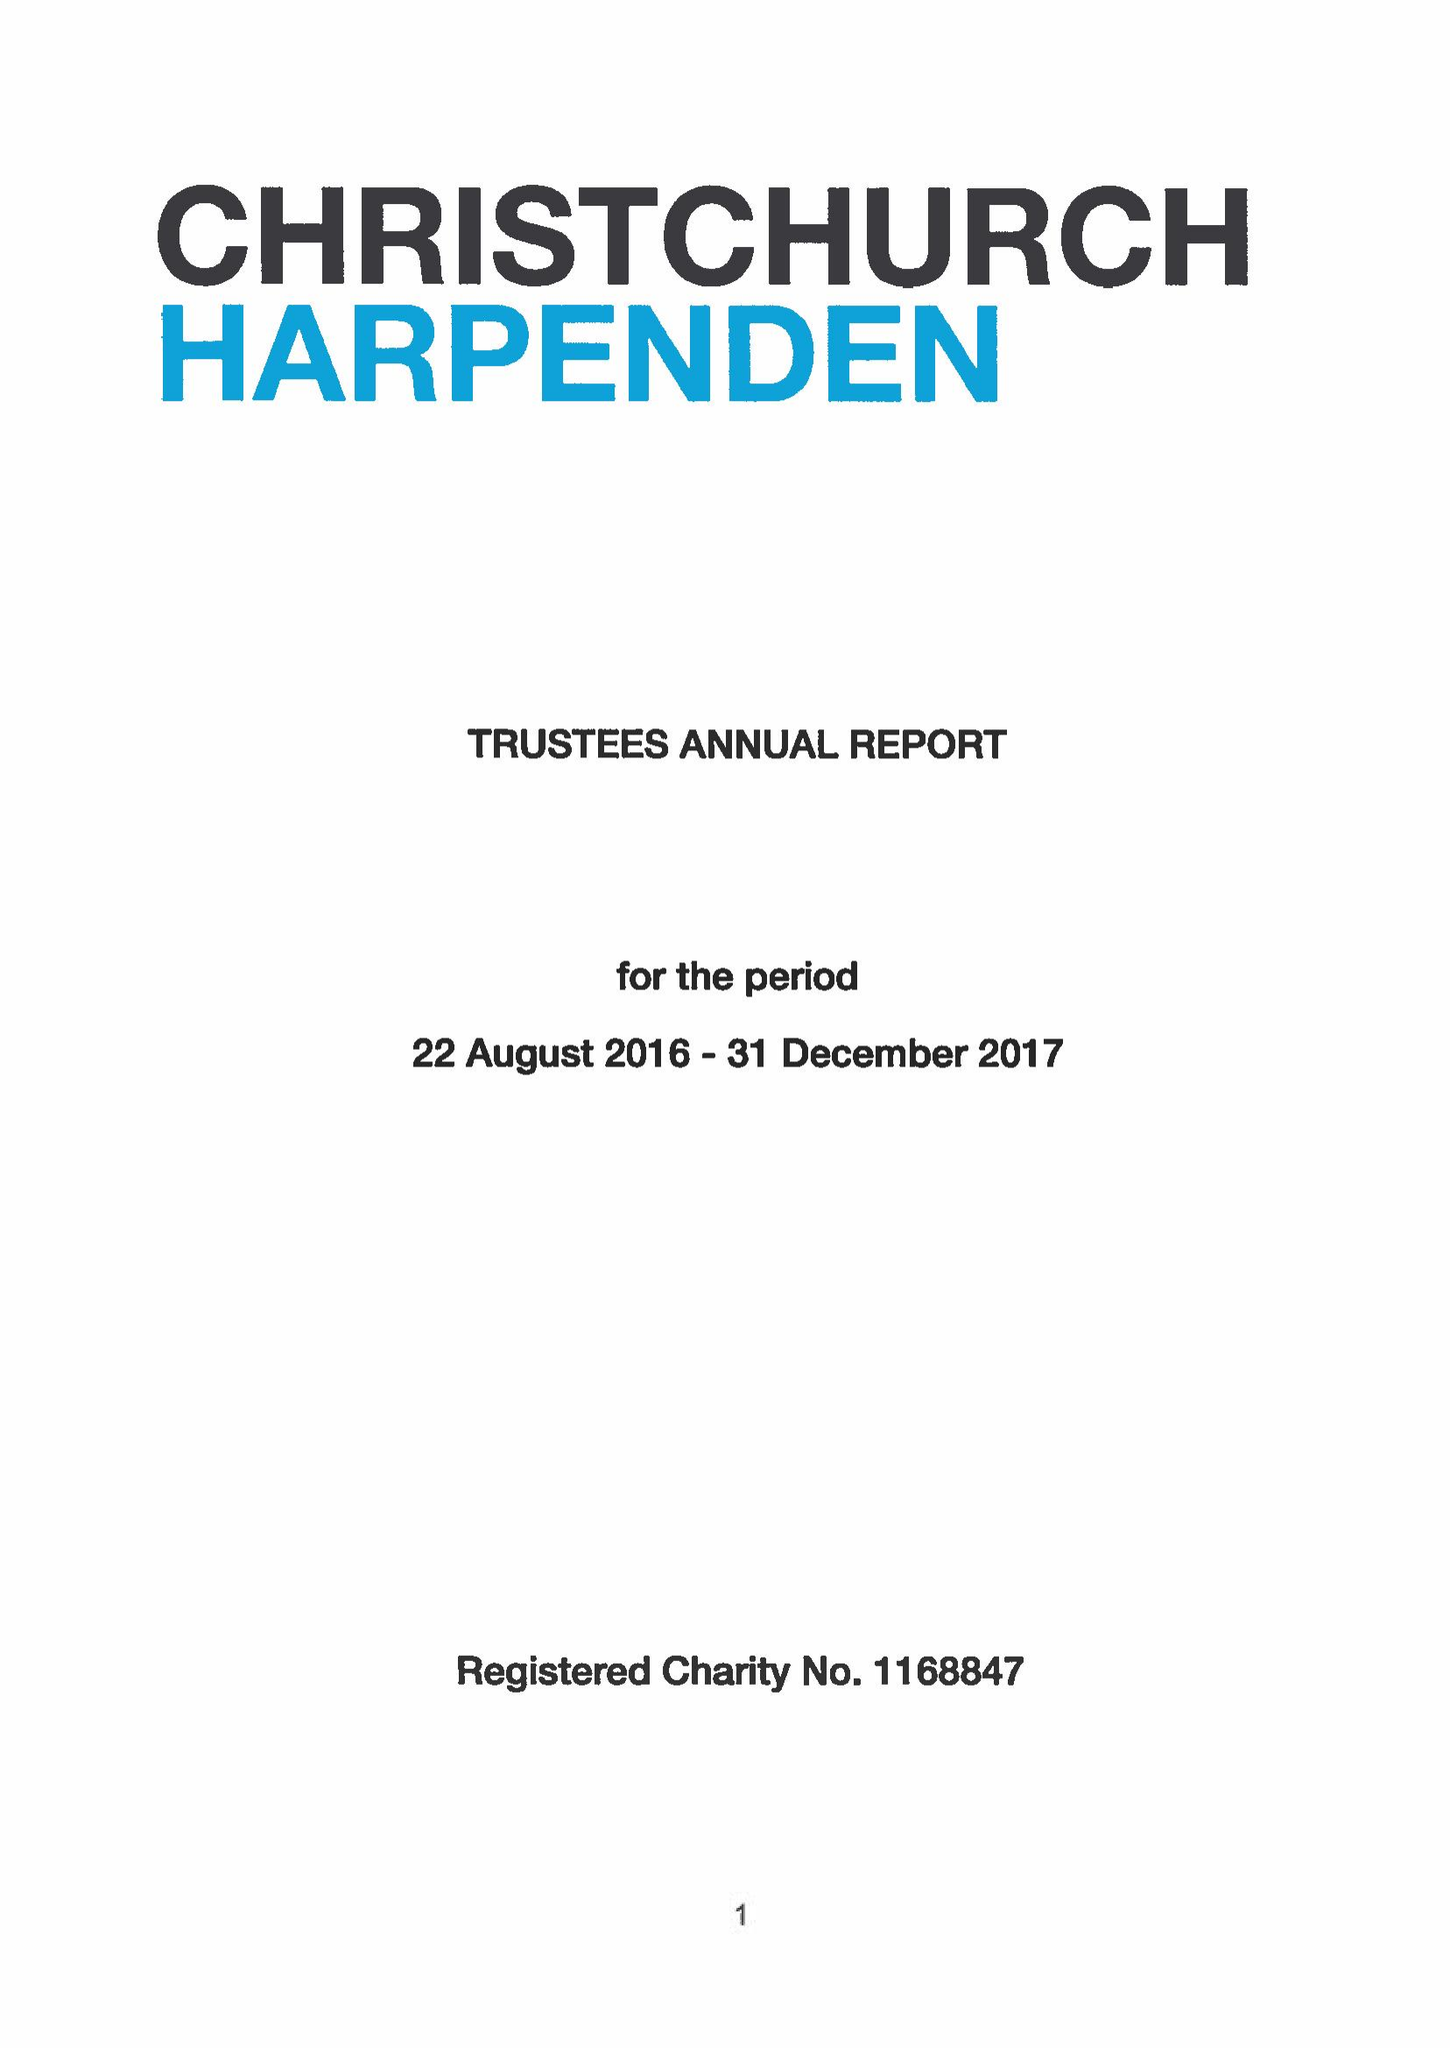What is the value for the charity_number?
Answer the question using a single word or phrase. 1168847 